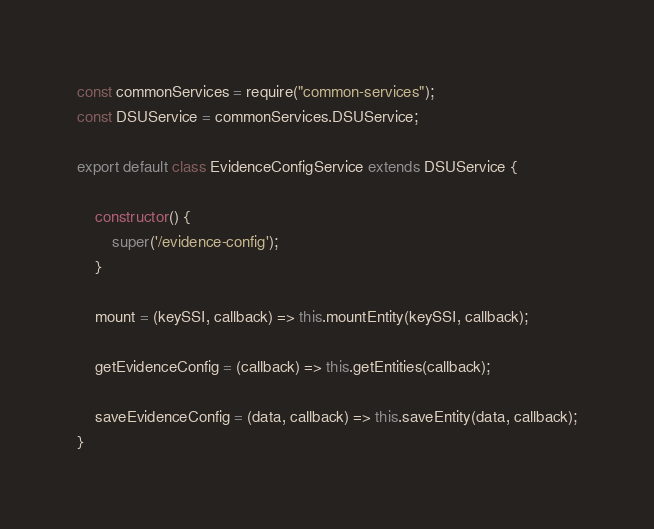<code> <loc_0><loc_0><loc_500><loc_500><_JavaScript_>const commonServices = require("common-services");
const DSUService = commonServices.DSUService;

export default class EvidenceConfigService extends DSUService {

    constructor() {
        super('/evidence-config');
    }

    mount = (keySSI, callback) => this.mountEntity(keySSI, callback);

    getEvidenceConfig = (callback) => this.getEntities(callback);

    saveEvidenceConfig = (data, callback) => this.saveEntity(data, callback);
}</code> 